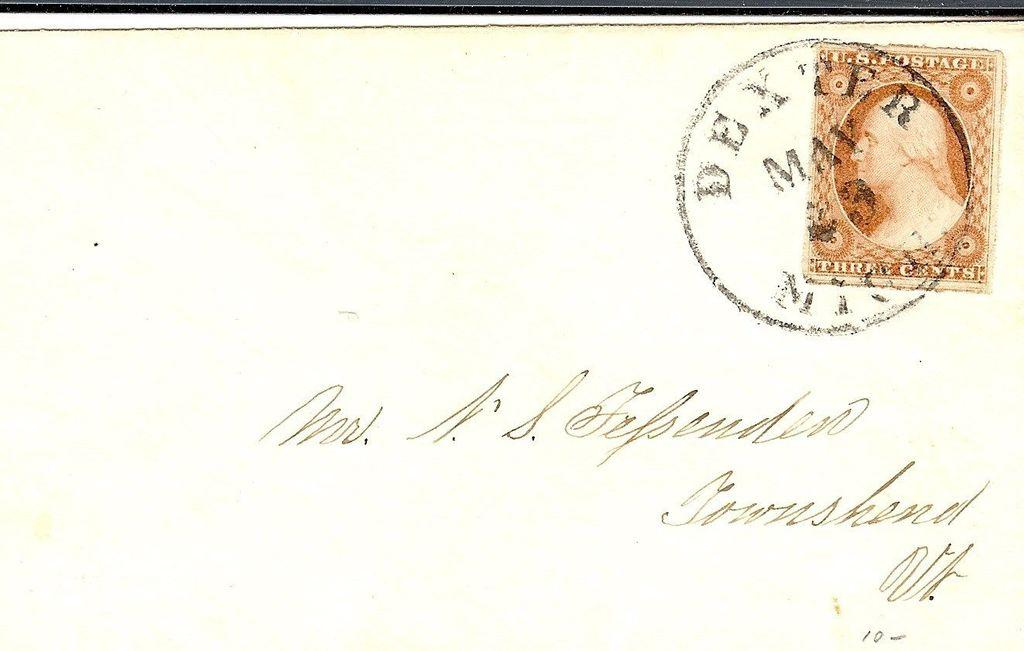Provide a one-sentence caption for the provided image. A letter that was postmarked from Dexter, MI in May. 